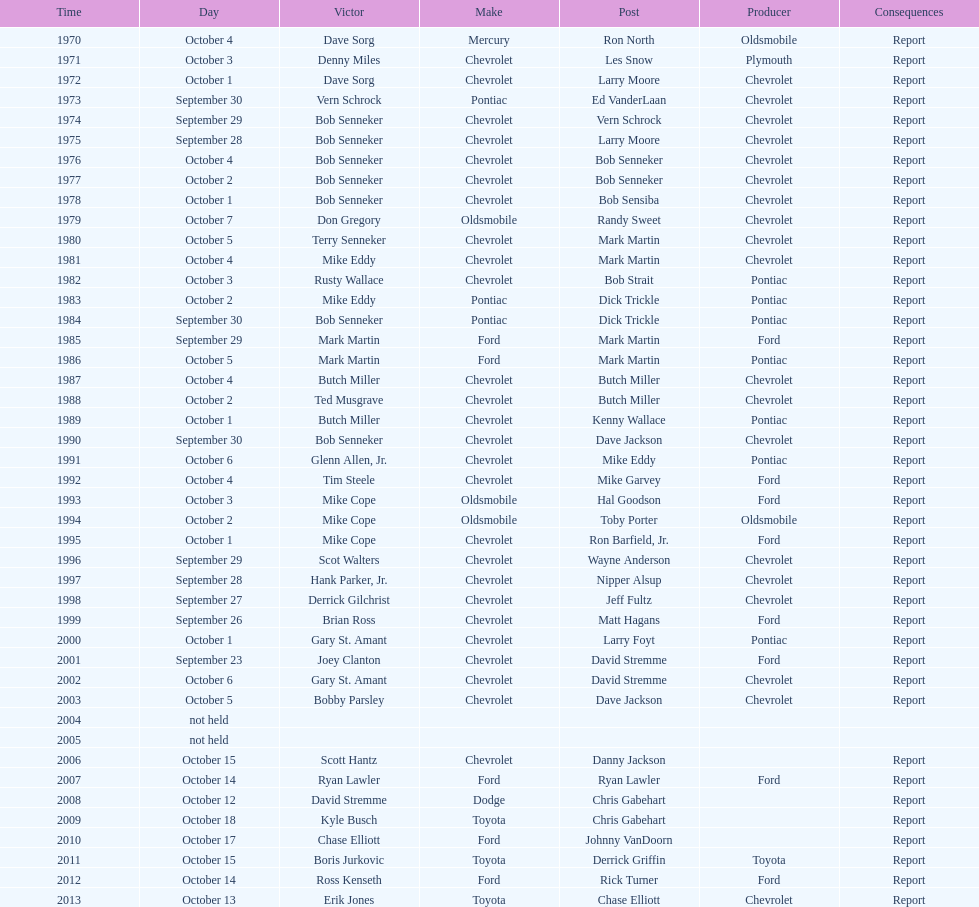Give me the full table as a dictionary. {'header': ['Time', 'Day', 'Victor', 'Make', 'Post', 'Producer', 'Consequences'], 'rows': [['1970', 'October 4', 'Dave Sorg', 'Mercury', 'Ron North', 'Oldsmobile', 'Report'], ['1971', 'October 3', 'Denny Miles', 'Chevrolet', 'Les Snow', 'Plymouth', 'Report'], ['1972', 'October 1', 'Dave Sorg', 'Chevrolet', 'Larry Moore', 'Chevrolet', 'Report'], ['1973', 'September 30', 'Vern Schrock', 'Pontiac', 'Ed VanderLaan', 'Chevrolet', 'Report'], ['1974', 'September 29', 'Bob Senneker', 'Chevrolet', 'Vern Schrock', 'Chevrolet', 'Report'], ['1975', 'September 28', 'Bob Senneker', 'Chevrolet', 'Larry Moore', 'Chevrolet', 'Report'], ['1976', 'October 4', 'Bob Senneker', 'Chevrolet', 'Bob Senneker', 'Chevrolet', 'Report'], ['1977', 'October 2', 'Bob Senneker', 'Chevrolet', 'Bob Senneker', 'Chevrolet', 'Report'], ['1978', 'October 1', 'Bob Senneker', 'Chevrolet', 'Bob Sensiba', 'Chevrolet', 'Report'], ['1979', 'October 7', 'Don Gregory', 'Oldsmobile', 'Randy Sweet', 'Chevrolet', 'Report'], ['1980', 'October 5', 'Terry Senneker', 'Chevrolet', 'Mark Martin', 'Chevrolet', 'Report'], ['1981', 'October 4', 'Mike Eddy', 'Chevrolet', 'Mark Martin', 'Chevrolet', 'Report'], ['1982', 'October 3', 'Rusty Wallace', 'Chevrolet', 'Bob Strait', 'Pontiac', 'Report'], ['1983', 'October 2', 'Mike Eddy', 'Pontiac', 'Dick Trickle', 'Pontiac', 'Report'], ['1984', 'September 30', 'Bob Senneker', 'Pontiac', 'Dick Trickle', 'Pontiac', 'Report'], ['1985', 'September 29', 'Mark Martin', 'Ford', 'Mark Martin', 'Ford', 'Report'], ['1986', 'October 5', 'Mark Martin', 'Ford', 'Mark Martin', 'Pontiac', 'Report'], ['1987', 'October 4', 'Butch Miller', 'Chevrolet', 'Butch Miller', 'Chevrolet', 'Report'], ['1988', 'October 2', 'Ted Musgrave', 'Chevrolet', 'Butch Miller', 'Chevrolet', 'Report'], ['1989', 'October 1', 'Butch Miller', 'Chevrolet', 'Kenny Wallace', 'Pontiac', 'Report'], ['1990', 'September 30', 'Bob Senneker', 'Chevrolet', 'Dave Jackson', 'Chevrolet', 'Report'], ['1991', 'October 6', 'Glenn Allen, Jr.', 'Chevrolet', 'Mike Eddy', 'Pontiac', 'Report'], ['1992', 'October 4', 'Tim Steele', 'Chevrolet', 'Mike Garvey', 'Ford', 'Report'], ['1993', 'October 3', 'Mike Cope', 'Oldsmobile', 'Hal Goodson', 'Ford', 'Report'], ['1994', 'October 2', 'Mike Cope', 'Oldsmobile', 'Toby Porter', 'Oldsmobile', 'Report'], ['1995', 'October 1', 'Mike Cope', 'Chevrolet', 'Ron Barfield, Jr.', 'Ford', 'Report'], ['1996', 'September 29', 'Scot Walters', 'Chevrolet', 'Wayne Anderson', 'Chevrolet', 'Report'], ['1997', 'September 28', 'Hank Parker, Jr.', 'Chevrolet', 'Nipper Alsup', 'Chevrolet', 'Report'], ['1998', 'September 27', 'Derrick Gilchrist', 'Chevrolet', 'Jeff Fultz', 'Chevrolet', 'Report'], ['1999', 'September 26', 'Brian Ross', 'Chevrolet', 'Matt Hagans', 'Ford', 'Report'], ['2000', 'October 1', 'Gary St. Amant', 'Chevrolet', 'Larry Foyt', 'Pontiac', 'Report'], ['2001', 'September 23', 'Joey Clanton', 'Chevrolet', 'David Stremme', 'Ford', 'Report'], ['2002', 'October 6', 'Gary St. Amant', 'Chevrolet', 'David Stremme', 'Chevrolet', 'Report'], ['2003', 'October 5', 'Bobby Parsley', 'Chevrolet', 'Dave Jackson', 'Chevrolet', 'Report'], ['2004', 'not held', '', '', '', '', ''], ['2005', 'not held', '', '', '', '', ''], ['2006', 'October 15', 'Scott Hantz', 'Chevrolet', 'Danny Jackson', '', 'Report'], ['2007', 'October 14', 'Ryan Lawler', 'Ford', 'Ryan Lawler', 'Ford', 'Report'], ['2008', 'October 12', 'David Stremme', 'Dodge', 'Chris Gabehart', '', 'Report'], ['2009', 'October 18', 'Kyle Busch', 'Toyota', 'Chris Gabehart', '', 'Report'], ['2010', 'October 17', 'Chase Elliott', 'Ford', 'Johnny VanDoorn', '', 'Report'], ['2011', 'October 15', 'Boris Jurkovic', 'Toyota', 'Derrick Griffin', 'Toyota', 'Report'], ['2012', 'October 14', 'Ross Kenseth', 'Ford', 'Rick Turner', 'Ford', 'Report'], ['2013', 'October 13', 'Erik Jones', 'Toyota', 'Chase Elliott', 'Chevrolet', 'Report']]} Which make of car was used the least by those that won races? Toyota. 